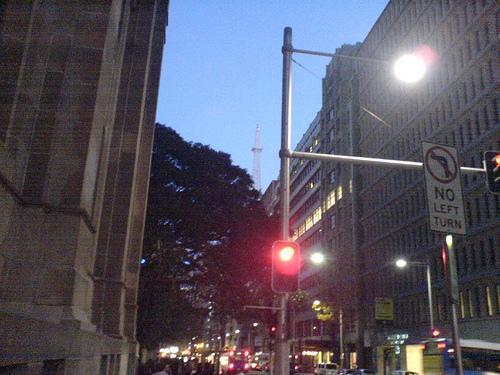How many traffic lights are there?
Give a very brief answer. 1. How many orange bananas are there?
Give a very brief answer. 0. 